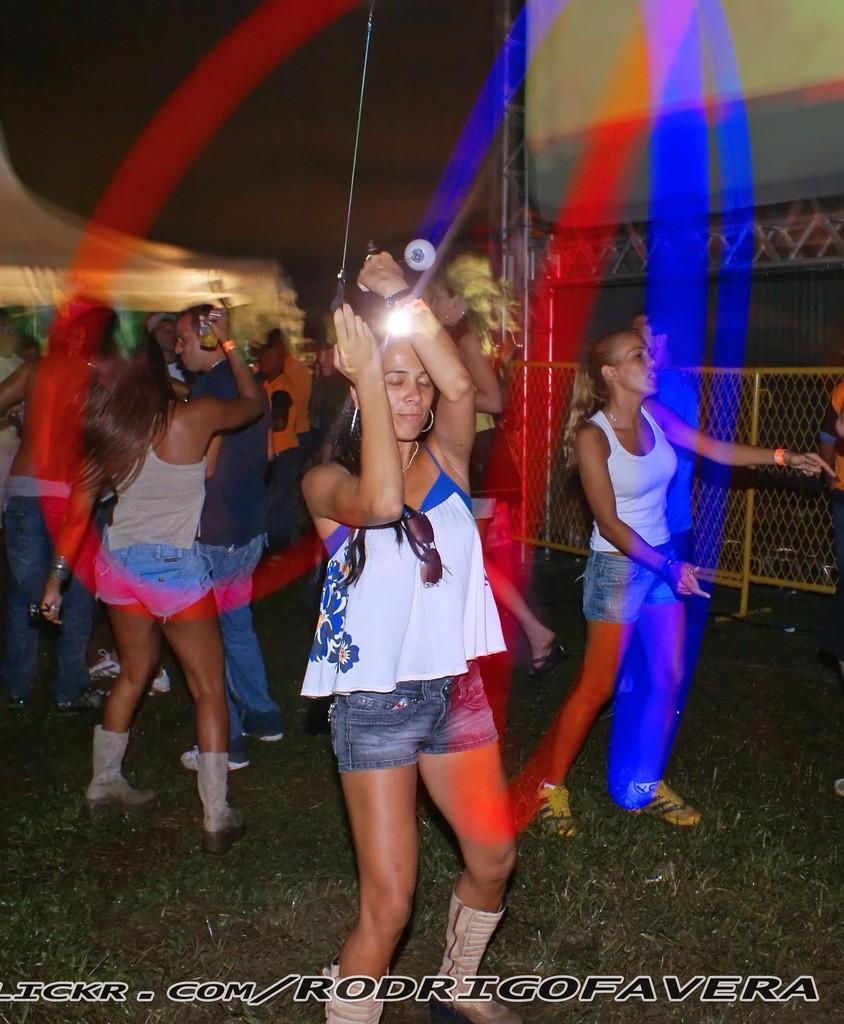In one or two sentences, can you explain what this image depicts? In this image we can see men and women are dancing. One girl is wearing white top with shorts and holding something in her hand. Right side of the image yellow color fence is present. Bottom of the image watermark is there. 